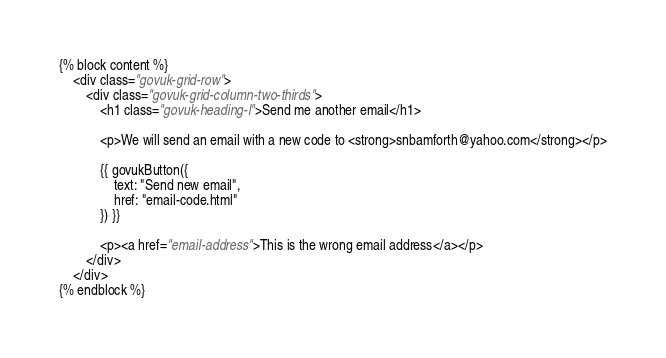<code> <loc_0><loc_0><loc_500><loc_500><_HTML_>
{% block content %}
    <div class="govuk-grid-row">
        <div class="govuk-grid-column-two-thirds">
            <h1 class="govuk-heading-l">Send me another email</h1>

            <p>We will send an email with a new code to <strong>snbamforth@yahoo.com</strong></p>

            {{ govukButton({
                text: "Send new email",
                href: "email-code.html"
            }) }}

            <p><a href="email-address">This is the wrong email address</a></p>
        </div>
    </div>
{% endblock %}
</code> 